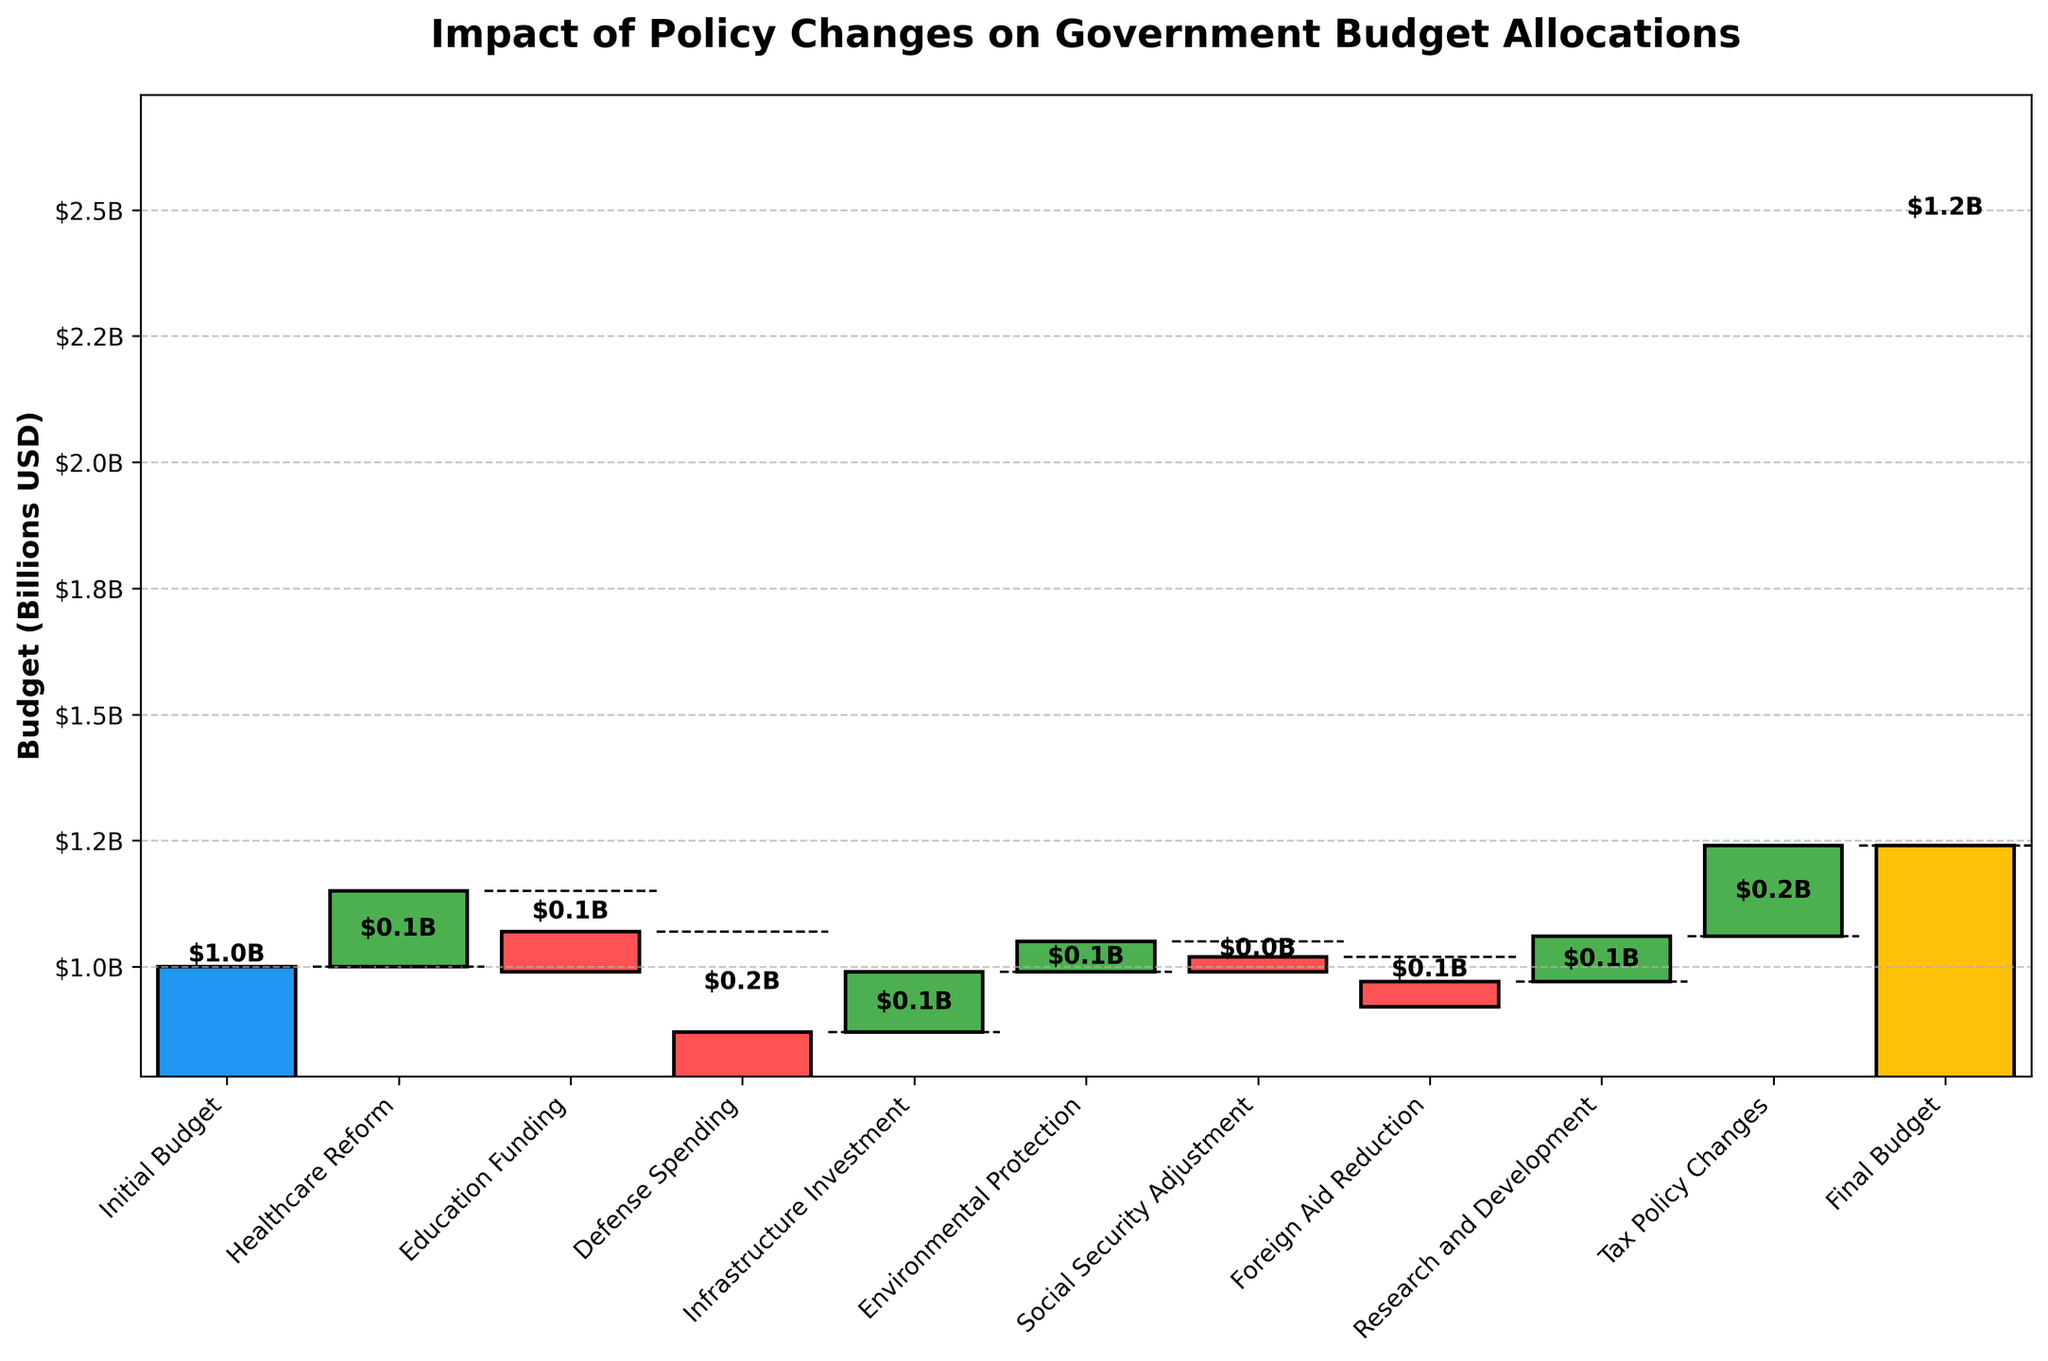What is the initial budget shown in the waterfall chart? The initial budget value is indicated by the first bar in the chart, which is distinctively colored and labeled.
Answer: $1.0B How much did healthcare reform contribute to the budget change? The healthcare reform is shown by a green bar indicating an increase. The value is labeled as $0.15B.
Answer: $0.15B Which category caused the largest reduction in the budget? By visual inspection, the category with the largest red bar (indicating a decrease) is Defense Spending.
Answer: Defense Spending How does the final budget compare to the initial budget? The final budget is represented by the last yellow bar and labeled as $1.24B, while the initial budget is $1.0B, showing an increase.
Answer: Increased What is the combined impact of education funding and foreign aid reduction on the budget? Education funding reduced the budget by $0.08B and foreign aid reduction reduced it by $0.05B. Summing these reductions: $0.08B + $0.05B = $0.13B.
Answer: $0.13B reduction Which category added the highest positive value to the budget? The tallest green bar represents the largest positive addition to the budget, which is Tax Policy Changes.
Answer: Tax Policy Changes What is the net effect of social security adjustment and infrastructure investment? Social security adjustment decreases by $0.03B and infrastructure investment increases by $0.12B. Net effect: $0.12B - $0.03B = $0.09B.
Answer: $0.09B increase How many categories decreased the budget allocation? By identifying the red bars which indicate decreases, the categories are Education Funding, Defense Spending, Social Security Adjustment, and Foreign Aid Reduction.
Answer: Four What does the black dashed line in the waterfall chart represent? The black dashed line serves as a visual aid connecting the cumulative budget values between each step, indicating the transition between each category.
Answer: Cumulative budget transitions Explain the total budget change due to the policy changes. The initial budget is $1.0B; through various increments and decrements, the final budget is $1.24B. The difference (final - initial) is $1.24B - $1.0B = $0.24B.
Answer: $0.24B increase 